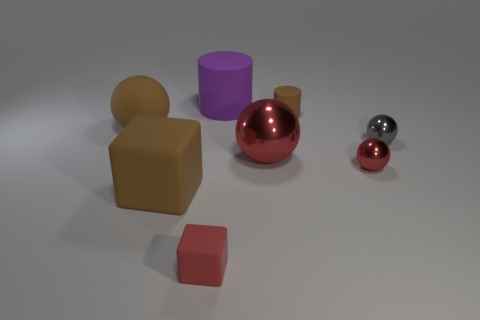There is a big brown object behind the big rubber block; is there a big sphere behind it?
Your answer should be compact. No. What is the size of the purple cylinder?
Keep it short and to the point. Large. There is a red thing that is left of the tiny brown matte thing and behind the small cube; what shape is it?
Your answer should be very brief. Sphere. How many purple things are either metal objects or large matte blocks?
Offer a very short reply. 0. There is a red ball in front of the big red metallic sphere; is its size the same as the brown matte thing right of the red rubber cube?
Ensure brevity in your answer.  Yes. What number of things are either big rubber cylinders or small yellow metal balls?
Your answer should be compact. 1. Is there a tiny object that has the same shape as the large metal thing?
Your answer should be compact. Yes. Are there fewer tiny shiny balls than rubber objects?
Ensure brevity in your answer.  Yes. Do the large red metal thing and the small brown rubber thing have the same shape?
Provide a short and direct response. No. What number of things are either blue shiny spheres or tiny gray shiny objects right of the large cylinder?
Provide a short and direct response. 1. 